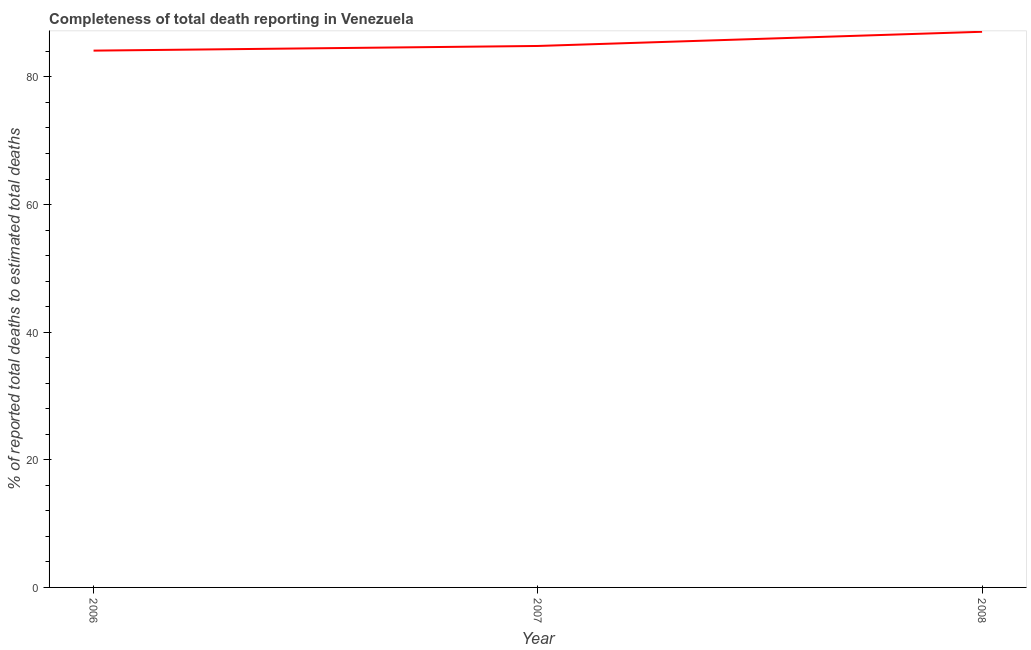What is the completeness of total death reports in 2007?
Give a very brief answer. 84.85. Across all years, what is the maximum completeness of total death reports?
Your answer should be very brief. 87.08. Across all years, what is the minimum completeness of total death reports?
Offer a terse response. 84.12. In which year was the completeness of total death reports maximum?
Give a very brief answer. 2008. What is the sum of the completeness of total death reports?
Your answer should be compact. 256.05. What is the difference between the completeness of total death reports in 2006 and 2007?
Your answer should be compact. -0.73. What is the average completeness of total death reports per year?
Provide a succinct answer. 85.35. What is the median completeness of total death reports?
Give a very brief answer. 84.85. Do a majority of the years between 2006 and 2007 (inclusive) have completeness of total death reports greater than 28 %?
Provide a short and direct response. Yes. What is the ratio of the completeness of total death reports in 2006 to that in 2008?
Your answer should be very brief. 0.97. Is the completeness of total death reports in 2006 less than that in 2008?
Your answer should be compact. Yes. Is the difference between the completeness of total death reports in 2007 and 2008 greater than the difference between any two years?
Your answer should be compact. No. What is the difference between the highest and the second highest completeness of total death reports?
Keep it short and to the point. 2.23. What is the difference between the highest and the lowest completeness of total death reports?
Provide a short and direct response. 2.96. In how many years, is the completeness of total death reports greater than the average completeness of total death reports taken over all years?
Keep it short and to the point. 1. How many years are there in the graph?
Ensure brevity in your answer.  3. Are the values on the major ticks of Y-axis written in scientific E-notation?
Provide a short and direct response. No. Does the graph contain any zero values?
Offer a terse response. No. Does the graph contain grids?
Keep it short and to the point. No. What is the title of the graph?
Your answer should be compact. Completeness of total death reporting in Venezuela. What is the label or title of the X-axis?
Your answer should be compact. Year. What is the label or title of the Y-axis?
Provide a succinct answer. % of reported total deaths to estimated total deaths. What is the % of reported total deaths to estimated total deaths of 2006?
Ensure brevity in your answer.  84.12. What is the % of reported total deaths to estimated total deaths of 2007?
Offer a terse response. 84.85. What is the % of reported total deaths to estimated total deaths in 2008?
Provide a short and direct response. 87.08. What is the difference between the % of reported total deaths to estimated total deaths in 2006 and 2007?
Your answer should be compact. -0.73. What is the difference between the % of reported total deaths to estimated total deaths in 2006 and 2008?
Your response must be concise. -2.96. What is the difference between the % of reported total deaths to estimated total deaths in 2007 and 2008?
Provide a succinct answer. -2.23. What is the ratio of the % of reported total deaths to estimated total deaths in 2007 to that in 2008?
Your answer should be compact. 0.97. 